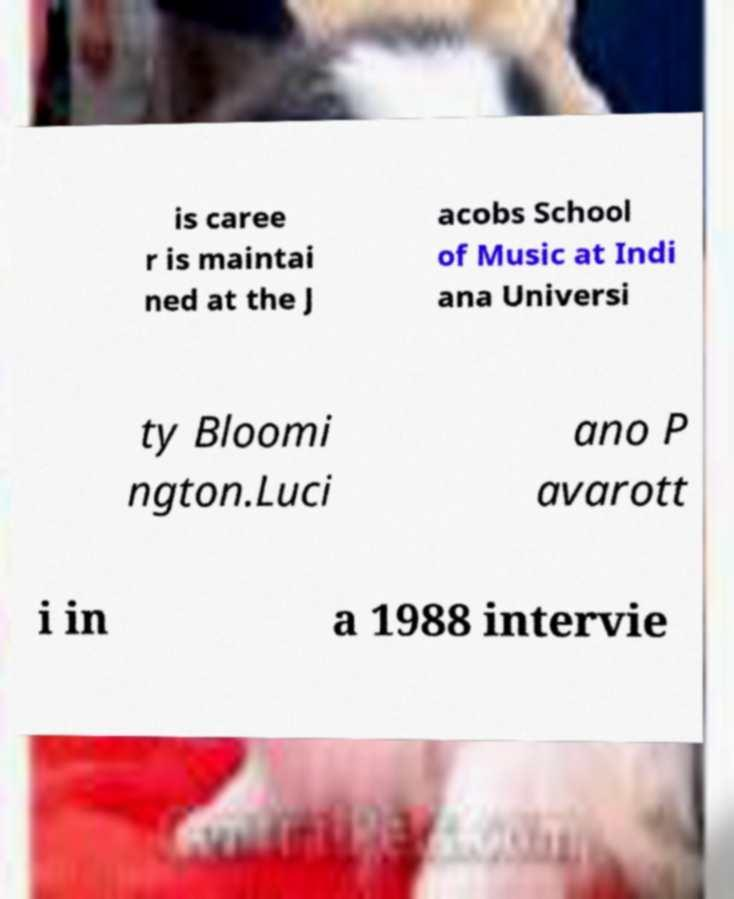Can you read and provide the text displayed in the image?This photo seems to have some interesting text. Can you extract and type it out for me? is caree r is maintai ned at the J acobs School of Music at Indi ana Universi ty Bloomi ngton.Luci ano P avarott i in a 1988 intervie 